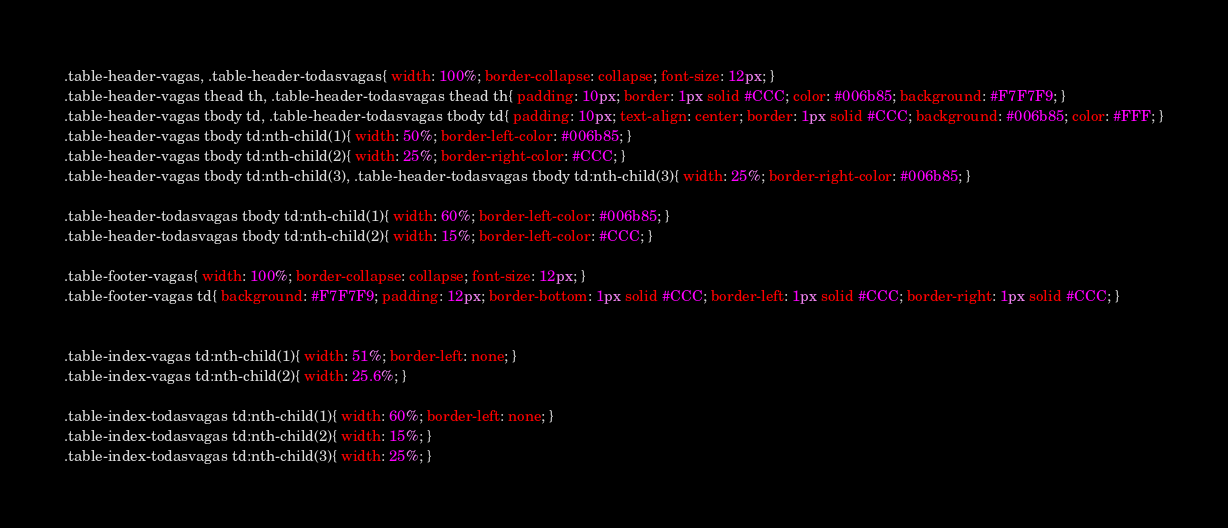<code> <loc_0><loc_0><loc_500><loc_500><_CSS_>.table-header-vagas, .table-header-todasvagas{ width: 100%; border-collapse: collapse; font-size: 12px; }
.table-header-vagas thead th, .table-header-todasvagas thead th{ padding: 10px; border: 1px solid #CCC; color: #006b85; background: #F7F7F9; }
.table-header-vagas tbody td, .table-header-todasvagas tbody td{ padding: 10px; text-align: center; border: 1px solid #CCC; background: #006b85; color: #FFF; }
.table-header-vagas tbody td:nth-child(1){ width: 50%; border-left-color: #006b85; }
.table-header-vagas tbody td:nth-child(2){ width: 25%; border-right-color: #CCC; }
.table-header-vagas tbody td:nth-child(3), .table-header-todasvagas tbody td:nth-child(3){ width: 25%; border-right-color: #006b85; }

.table-header-todasvagas tbody td:nth-child(1){ width: 60%; border-left-color: #006b85; }
.table-header-todasvagas tbody td:nth-child(2){ width: 15%; border-left-color: #CCC; }

.table-footer-vagas{ width: 100%; border-collapse: collapse; font-size: 12px; }
.table-footer-vagas td{ background: #F7F7F9; padding: 12px; border-bottom: 1px solid #CCC; border-left: 1px solid #CCC; border-right: 1px solid #CCC; }


.table-index-vagas td:nth-child(1){ width: 51%; border-left: none; }
.table-index-vagas td:nth-child(2){ width: 25.6%; }

.table-index-todasvagas td:nth-child(1){ width: 60%; border-left: none; }
.table-index-todasvagas td:nth-child(2){ width: 15%; }
.table-index-todasvagas td:nth-child(3){ width: 25%; }
</code> 